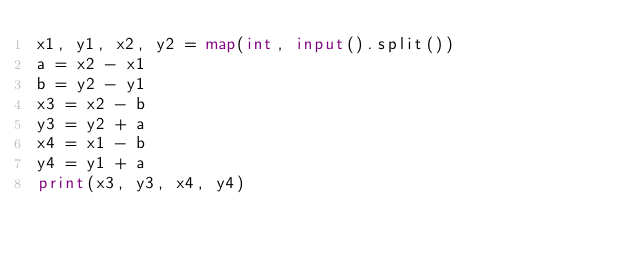<code> <loc_0><loc_0><loc_500><loc_500><_Python_>x1, y1, x2, y2 = map(int, input().split())
a = x2 - x1
b = y2 - y1
x3 = x2 - b
y3 = y2 + a
x4 = x1 - b
y4 = y1 + a
print(x3, y3, x4, y4)</code> 